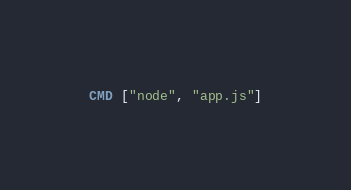Convert code to text. <code><loc_0><loc_0><loc_500><loc_500><_Dockerfile_>CMD ["node", "app.js"]

</code> 